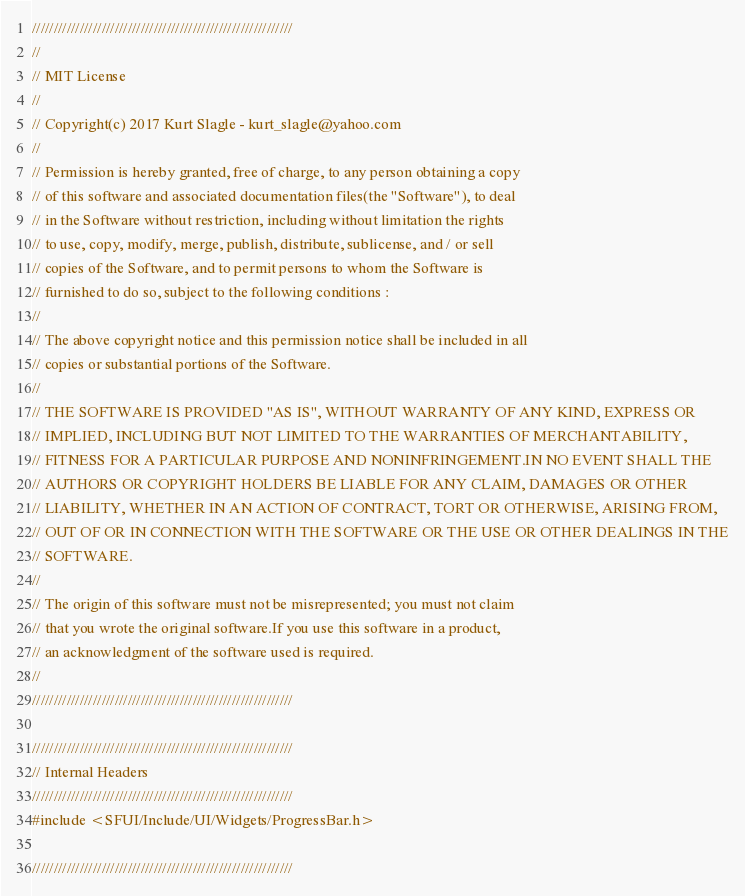<code> <loc_0><loc_0><loc_500><loc_500><_C++_>////////////////////////////////////////////////////////////
//
// MIT License
//
// Copyright(c) 2017 Kurt Slagle - kurt_slagle@yahoo.com
// 
// Permission is hereby granted, free of charge, to any person obtaining a copy
// of this software and associated documentation files(the "Software"), to deal
// in the Software without restriction, including without limitation the rights
// to use, copy, modify, merge, publish, distribute, sublicense, and / or sell
// copies of the Software, and to permit persons to whom the Software is
// furnished to do so, subject to the following conditions :
//
// The above copyright notice and this permission notice shall be included in all
// copies or substantial portions of the Software.
//
// THE SOFTWARE IS PROVIDED "AS IS", WITHOUT WARRANTY OF ANY KIND, EXPRESS OR
// IMPLIED, INCLUDING BUT NOT LIMITED TO THE WARRANTIES OF MERCHANTABILITY,
// FITNESS FOR A PARTICULAR PURPOSE AND NONINFRINGEMENT.IN NO EVENT SHALL THE
// AUTHORS OR COPYRIGHT HOLDERS BE LIABLE FOR ANY CLAIM, DAMAGES OR OTHER
// LIABILITY, WHETHER IN AN ACTION OF CONTRACT, TORT OR OTHERWISE, ARISING FROM,
// OUT OF OR IN CONNECTION WITH THE SOFTWARE OR THE USE OR OTHER DEALINGS IN THE
// SOFTWARE.
//
// The origin of this software must not be misrepresented; you must not claim
// that you wrote the original software.If you use this software in a product,
// an acknowledgment of the software used is required.
//
////////////////////////////////////////////////////////////

////////////////////////////////////////////////////////////
// Internal Headers
////////////////////////////////////////////////////////////
#include <SFUI/Include/UI/Widgets/ProgressBar.h>

////////////////////////////////////////////////////////////</code> 